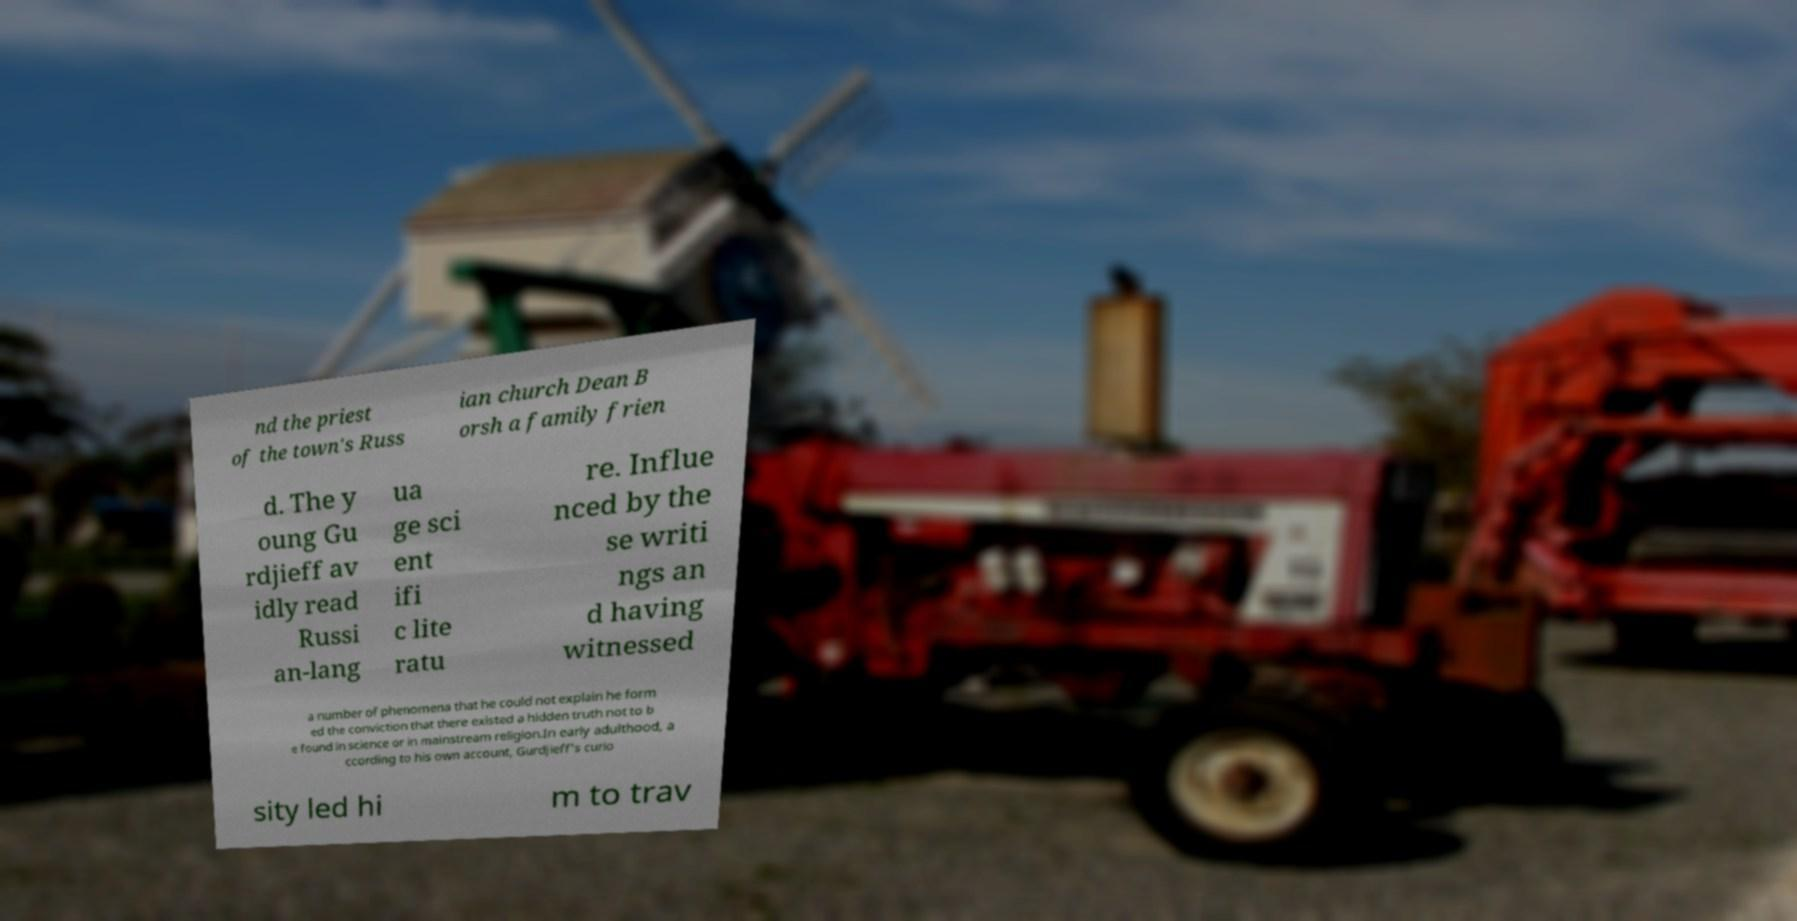Can you read and provide the text displayed in the image?This photo seems to have some interesting text. Can you extract and type it out for me? nd the priest of the town's Russ ian church Dean B orsh a family frien d. The y oung Gu rdjieff av idly read Russi an-lang ua ge sci ent ifi c lite ratu re. Influe nced by the se writi ngs an d having witnessed a number of phenomena that he could not explain he form ed the conviction that there existed a hidden truth not to b e found in science or in mainstream religion.In early adulthood, a ccording to his own account, Gurdjieff's curio sity led hi m to trav 